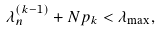<formula> <loc_0><loc_0><loc_500><loc_500>\lambda _ { n } ^ { ( k - 1 ) } + N p _ { k } < \lambda _ { \max } ,</formula> 